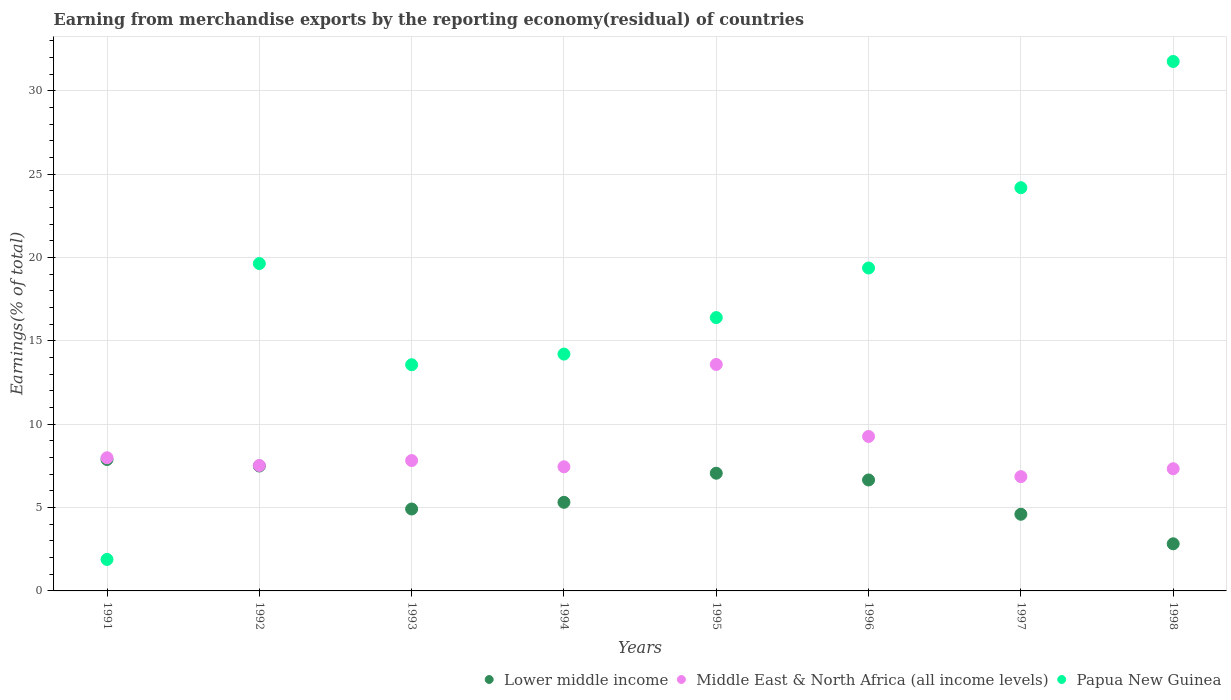How many different coloured dotlines are there?
Provide a succinct answer. 3. What is the percentage of amount earned from merchandise exports in Lower middle income in 1998?
Ensure brevity in your answer.  2.83. Across all years, what is the maximum percentage of amount earned from merchandise exports in Lower middle income?
Your response must be concise. 7.88. Across all years, what is the minimum percentage of amount earned from merchandise exports in Middle East & North Africa (all income levels)?
Offer a very short reply. 6.86. In which year was the percentage of amount earned from merchandise exports in Lower middle income maximum?
Offer a terse response. 1991. What is the total percentage of amount earned from merchandise exports in Papua New Guinea in the graph?
Your answer should be very brief. 141. What is the difference between the percentage of amount earned from merchandise exports in Papua New Guinea in 1994 and that in 1996?
Ensure brevity in your answer.  -5.16. What is the difference between the percentage of amount earned from merchandise exports in Lower middle income in 1997 and the percentage of amount earned from merchandise exports in Middle East & North Africa (all income levels) in 1996?
Provide a short and direct response. -4.67. What is the average percentage of amount earned from merchandise exports in Papua New Guinea per year?
Provide a short and direct response. 17.62. In the year 1993, what is the difference between the percentage of amount earned from merchandise exports in Middle East & North Africa (all income levels) and percentage of amount earned from merchandise exports in Lower middle income?
Make the answer very short. 2.91. In how many years, is the percentage of amount earned from merchandise exports in Middle East & North Africa (all income levels) greater than 25 %?
Offer a very short reply. 0. What is the ratio of the percentage of amount earned from merchandise exports in Lower middle income in 1993 to that in 1995?
Your answer should be compact. 0.7. Is the difference between the percentage of amount earned from merchandise exports in Middle East & North Africa (all income levels) in 1994 and 1998 greater than the difference between the percentage of amount earned from merchandise exports in Lower middle income in 1994 and 1998?
Your answer should be very brief. No. What is the difference between the highest and the second highest percentage of amount earned from merchandise exports in Middle East & North Africa (all income levels)?
Offer a very short reply. 4.32. What is the difference between the highest and the lowest percentage of amount earned from merchandise exports in Lower middle income?
Give a very brief answer. 5.06. Does the percentage of amount earned from merchandise exports in Lower middle income monotonically increase over the years?
Your answer should be compact. No. Is the percentage of amount earned from merchandise exports in Middle East & North Africa (all income levels) strictly greater than the percentage of amount earned from merchandise exports in Lower middle income over the years?
Make the answer very short. Yes. How many dotlines are there?
Offer a very short reply. 3. How many years are there in the graph?
Provide a short and direct response. 8. What is the difference between two consecutive major ticks on the Y-axis?
Offer a terse response. 5. Are the values on the major ticks of Y-axis written in scientific E-notation?
Make the answer very short. No. Does the graph contain any zero values?
Provide a short and direct response. No. Does the graph contain grids?
Keep it short and to the point. Yes. Where does the legend appear in the graph?
Ensure brevity in your answer.  Bottom right. How many legend labels are there?
Offer a very short reply. 3. What is the title of the graph?
Give a very brief answer. Earning from merchandise exports by the reporting economy(residual) of countries. Does "India" appear as one of the legend labels in the graph?
Keep it short and to the point. No. What is the label or title of the Y-axis?
Provide a short and direct response. Earnings(% of total). What is the Earnings(% of total) of Lower middle income in 1991?
Offer a terse response. 7.88. What is the Earnings(% of total) in Middle East & North Africa (all income levels) in 1991?
Offer a very short reply. 7.99. What is the Earnings(% of total) in Papua New Guinea in 1991?
Provide a short and direct response. 1.89. What is the Earnings(% of total) of Lower middle income in 1992?
Offer a very short reply. 7.49. What is the Earnings(% of total) of Middle East & North Africa (all income levels) in 1992?
Your answer should be very brief. 7.52. What is the Earnings(% of total) of Papua New Guinea in 1992?
Provide a succinct answer. 19.64. What is the Earnings(% of total) in Lower middle income in 1993?
Offer a very short reply. 4.91. What is the Earnings(% of total) of Middle East & North Africa (all income levels) in 1993?
Your answer should be very brief. 7.82. What is the Earnings(% of total) in Papua New Guinea in 1993?
Keep it short and to the point. 13.57. What is the Earnings(% of total) in Lower middle income in 1994?
Make the answer very short. 5.32. What is the Earnings(% of total) in Middle East & North Africa (all income levels) in 1994?
Keep it short and to the point. 7.45. What is the Earnings(% of total) in Papua New Guinea in 1994?
Provide a short and direct response. 14.21. What is the Earnings(% of total) in Lower middle income in 1995?
Offer a very short reply. 7.06. What is the Earnings(% of total) of Middle East & North Africa (all income levels) in 1995?
Offer a very short reply. 13.58. What is the Earnings(% of total) in Papua New Guinea in 1995?
Give a very brief answer. 16.39. What is the Earnings(% of total) of Lower middle income in 1996?
Provide a short and direct response. 6.66. What is the Earnings(% of total) in Middle East & North Africa (all income levels) in 1996?
Your answer should be compact. 9.26. What is the Earnings(% of total) in Papua New Guinea in 1996?
Make the answer very short. 19.37. What is the Earnings(% of total) of Lower middle income in 1997?
Offer a very short reply. 4.6. What is the Earnings(% of total) in Middle East & North Africa (all income levels) in 1997?
Your answer should be compact. 6.86. What is the Earnings(% of total) of Papua New Guinea in 1997?
Your response must be concise. 24.19. What is the Earnings(% of total) in Lower middle income in 1998?
Provide a succinct answer. 2.83. What is the Earnings(% of total) of Middle East & North Africa (all income levels) in 1998?
Offer a terse response. 7.33. What is the Earnings(% of total) in Papua New Guinea in 1998?
Your answer should be very brief. 31.76. Across all years, what is the maximum Earnings(% of total) in Lower middle income?
Provide a short and direct response. 7.88. Across all years, what is the maximum Earnings(% of total) of Middle East & North Africa (all income levels)?
Keep it short and to the point. 13.58. Across all years, what is the maximum Earnings(% of total) in Papua New Guinea?
Provide a short and direct response. 31.76. Across all years, what is the minimum Earnings(% of total) of Lower middle income?
Ensure brevity in your answer.  2.83. Across all years, what is the minimum Earnings(% of total) in Middle East & North Africa (all income levels)?
Your answer should be compact. 6.86. Across all years, what is the minimum Earnings(% of total) of Papua New Guinea?
Give a very brief answer. 1.89. What is the total Earnings(% of total) of Lower middle income in the graph?
Keep it short and to the point. 46.74. What is the total Earnings(% of total) in Middle East & North Africa (all income levels) in the graph?
Your answer should be compact. 67.81. What is the total Earnings(% of total) in Papua New Guinea in the graph?
Give a very brief answer. 141. What is the difference between the Earnings(% of total) in Lower middle income in 1991 and that in 1992?
Offer a terse response. 0.39. What is the difference between the Earnings(% of total) in Middle East & North Africa (all income levels) in 1991 and that in 1992?
Provide a short and direct response. 0.46. What is the difference between the Earnings(% of total) in Papua New Guinea in 1991 and that in 1992?
Offer a terse response. -17.75. What is the difference between the Earnings(% of total) of Lower middle income in 1991 and that in 1993?
Ensure brevity in your answer.  2.97. What is the difference between the Earnings(% of total) of Middle East & North Africa (all income levels) in 1991 and that in 1993?
Your answer should be compact. 0.17. What is the difference between the Earnings(% of total) in Papua New Guinea in 1991 and that in 1993?
Offer a very short reply. -11.68. What is the difference between the Earnings(% of total) in Lower middle income in 1991 and that in 1994?
Provide a succinct answer. 2.57. What is the difference between the Earnings(% of total) in Middle East & North Africa (all income levels) in 1991 and that in 1994?
Ensure brevity in your answer.  0.54. What is the difference between the Earnings(% of total) of Papua New Guinea in 1991 and that in 1994?
Your answer should be compact. -12.32. What is the difference between the Earnings(% of total) in Lower middle income in 1991 and that in 1995?
Provide a succinct answer. 0.82. What is the difference between the Earnings(% of total) of Middle East & North Africa (all income levels) in 1991 and that in 1995?
Your answer should be compact. -5.6. What is the difference between the Earnings(% of total) of Papua New Guinea in 1991 and that in 1995?
Your response must be concise. -14.51. What is the difference between the Earnings(% of total) of Lower middle income in 1991 and that in 1996?
Provide a short and direct response. 1.23. What is the difference between the Earnings(% of total) in Middle East & North Africa (all income levels) in 1991 and that in 1996?
Your answer should be compact. -1.28. What is the difference between the Earnings(% of total) of Papua New Guinea in 1991 and that in 1996?
Your answer should be compact. -17.48. What is the difference between the Earnings(% of total) of Lower middle income in 1991 and that in 1997?
Offer a terse response. 3.29. What is the difference between the Earnings(% of total) of Middle East & North Africa (all income levels) in 1991 and that in 1997?
Offer a terse response. 1.13. What is the difference between the Earnings(% of total) of Papua New Guinea in 1991 and that in 1997?
Offer a terse response. -22.3. What is the difference between the Earnings(% of total) in Lower middle income in 1991 and that in 1998?
Your answer should be very brief. 5.06. What is the difference between the Earnings(% of total) of Middle East & North Africa (all income levels) in 1991 and that in 1998?
Ensure brevity in your answer.  0.66. What is the difference between the Earnings(% of total) of Papua New Guinea in 1991 and that in 1998?
Offer a very short reply. -29.87. What is the difference between the Earnings(% of total) in Lower middle income in 1992 and that in 1993?
Your response must be concise. 2.58. What is the difference between the Earnings(% of total) in Middle East & North Africa (all income levels) in 1992 and that in 1993?
Give a very brief answer. -0.29. What is the difference between the Earnings(% of total) in Papua New Guinea in 1992 and that in 1993?
Your answer should be compact. 6.07. What is the difference between the Earnings(% of total) of Lower middle income in 1992 and that in 1994?
Provide a succinct answer. 2.18. What is the difference between the Earnings(% of total) of Middle East & North Africa (all income levels) in 1992 and that in 1994?
Give a very brief answer. 0.08. What is the difference between the Earnings(% of total) of Papua New Guinea in 1992 and that in 1994?
Ensure brevity in your answer.  5.43. What is the difference between the Earnings(% of total) of Lower middle income in 1992 and that in 1995?
Ensure brevity in your answer.  0.43. What is the difference between the Earnings(% of total) in Middle East & North Africa (all income levels) in 1992 and that in 1995?
Your response must be concise. -6.06. What is the difference between the Earnings(% of total) of Papua New Guinea in 1992 and that in 1995?
Ensure brevity in your answer.  3.24. What is the difference between the Earnings(% of total) in Lower middle income in 1992 and that in 1996?
Offer a terse response. 0.84. What is the difference between the Earnings(% of total) of Middle East & North Africa (all income levels) in 1992 and that in 1996?
Provide a succinct answer. -1.74. What is the difference between the Earnings(% of total) of Papua New Guinea in 1992 and that in 1996?
Your answer should be compact. 0.27. What is the difference between the Earnings(% of total) in Lower middle income in 1992 and that in 1997?
Offer a terse response. 2.89. What is the difference between the Earnings(% of total) of Middle East & North Africa (all income levels) in 1992 and that in 1997?
Offer a very short reply. 0.67. What is the difference between the Earnings(% of total) in Papua New Guinea in 1992 and that in 1997?
Your response must be concise. -4.55. What is the difference between the Earnings(% of total) in Lower middle income in 1992 and that in 1998?
Your answer should be very brief. 4.67. What is the difference between the Earnings(% of total) in Middle East & North Africa (all income levels) in 1992 and that in 1998?
Your answer should be compact. 0.2. What is the difference between the Earnings(% of total) of Papua New Guinea in 1992 and that in 1998?
Keep it short and to the point. -12.12. What is the difference between the Earnings(% of total) in Lower middle income in 1993 and that in 1994?
Ensure brevity in your answer.  -0.4. What is the difference between the Earnings(% of total) of Middle East & North Africa (all income levels) in 1993 and that in 1994?
Offer a very short reply. 0.37. What is the difference between the Earnings(% of total) in Papua New Guinea in 1993 and that in 1994?
Make the answer very short. -0.64. What is the difference between the Earnings(% of total) in Lower middle income in 1993 and that in 1995?
Offer a terse response. -2.15. What is the difference between the Earnings(% of total) of Middle East & North Africa (all income levels) in 1993 and that in 1995?
Offer a terse response. -5.76. What is the difference between the Earnings(% of total) in Papua New Guinea in 1993 and that in 1995?
Offer a terse response. -2.83. What is the difference between the Earnings(% of total) in Lower middle income in 1993 and that in 1996?
Offer a terse response. -1.74. What is the difference between the Earnings(% of total) in Middle East & North Africa (all income levels) in 1993 and that in 1996?
Give a very brief answer. -1.45. What is the difference between the Earnings(% of total) in Papua New Guinea in 1993 and that in 1996?
Offer a very short reply. -5.8. What is the difference between the Earnings(% of total) in Lower middle income in 1993 and that in 1997?
Offer a very short reply. 0.32. What is the difference between the Earnings(% of total) in Middle East & North Africa (all income levels) in 1993 and that in 1997?
Provide a short and direct response. 0.96. What is the difference between the Earnings(% of total) in Papua New Guinea in 1993 and that in 1997?
Your response must be concise. -10.62. What is the difference between the Earnings(% of total) of Lower middle income in 1993 and that in 1998?
Your answer should be very brief. 2.09. What is the difference between the Earnings(% of total) in Middle East & North Africa (all income levels) in 1993 and that in 1998?
Ensure brevity in your answer.  0.49. What is the difference between the Earnings(% of total) of Papua New Guinea in 1993 and that in 1998?
Your answer should be compact. -18.19. What is the difference between the Earnings(% of total) of Lower middle income in 1994 and that in 1995?
Ensure brevity in your answer.  -1.74. What is the difference between the Earnings(% of total) in Middle East & North Africa (all income levels) in 1994 and that in 1995?
Offer a very short reply. -6.14. What is the difference between the Earnings(% of total) of Papua New Guinea in 1994 and that in 1995?
Provide a short and direct response. -2.19. What is the difference between the Earnings(% of total) in Lower middle income in 1994 and that in 1996?
Keep it short and to the point. -1.34. What is the difference between the Earnings(% of total) in Middle East & North Africa (all income levels) in 1994 and that in 1996?
Make the answer very short. -1.82. What is the difference between the Earnings(% of total) of Papua New Guinea in 1994 and that in 1996?
Give a very brief answer. -5.16. What is the difference between the Earnings(% of total) of Lower middle income in 1994 and that in 1997?
Your answer should be very brief. 0.72. What is the difference between the Earnings(% of total) of Middle East & North Africa (all income levels) in 1994 and that in 1997?
Make the answer very short. 0.59. What is the difference between the Earnings(% of total) of Papua New Guinea in 1994 and that in 1997?
Offer a terse response. -9.98. What is the difference between the Earnings(% of total) in Lower middle income in 1994 and that in 1998?
Your response must be concise. 2.49. What is the difference between the Earnings(% of total) of Middle East & North Africa (all income levels) in 1994 and that in 1998?
Offer a terse response. 0.12. What is the difference between the Earnings(% of total) in Papua New Guinea in 1994 and that in 1998?
Offer a very short reply. -17.55. What is the difference between the Earnings(% of total) in Lower middle income in 1995 and that in 1996?
Your answer should be compact. 0.4. What is the difference between the Earnings(% of total) of Middle East & North Africa (all income levels) in 1995 and that in 1996?
Ensure brevity in your answer.  4.32. What is the difference between the Earnings(% of total) in Papua New Guinea in 1995 and that in 1996?
Make the answer very short. -2.97. What is the difference between the Earnings(% of total) in Lower middle income in 1995 and that in 1997?
Your response must be concise. 2.46. What is the difference between the Earnings(% of total) in Middle East & North Africa (all income levels) in 1995 and that in 1997?
Your answer should be compact. 6.73. What is the difference between the Earnings(% of total) of Papua New Guinea in 1995 and that in 1997?
Keep it short and to the point. -7.79. What is the difference between the Earnings(% of total) of Lower middle income in 1995 and that in 1998?
Offer a very short reply. 4.23. What is the difference between the Earnings(% of total) in Middle East & North Africa (all income levels) in 1995 and that in 1998?
Offer a very short reply. 6.25. What is the difference between the Earnings(% of total) of Papua New Guinea in 1995 and that in 1998?
Keep it short and to the point. -15.36. What is the difference between the Earnings(% of total) of Lower middle income in 1996 and that in 1997?
Provide a succinct answer. 2.06. What is the difference between the Earnings(% of total) of Middle East & North Africa (all income levels) in 1996 and that in 1997?
Offer a terse response. 2.41. What is the difference between the Earnings(% of total) in Papua New Guinea in 1996 and that in 1997?
Offer a very short reply. -4.82. What is the difference between the Earnings(% of total) in Lower middle income in 1996 and that in 1998?
Your answer should be compact. 3.83. What is the difference between the Earnings(% of total) of Middle East & North Africa (all income levels) in 1996 and that in 1998?
Offer a terse response. 1.94. What is the difference between the Earnings(% of total) in Papua New Guinea in 1996 and that in 1998?
Ensure brevity in your answer.  -12.39. What is the difference between the Earnings(% of total) in Lower middle income in 1997 and that in 1998?
Give a very brief answer. 1.77. What is the difference between the Earnings(% of total) of Middle East & North Africa (all income levels) in 1997 and that in 1998?
Keep it short and to the point. -0.47. What is the difference between the Earnings(% of total) of Papua New Guinea in 1997 and that in 1998?
Provide a succinct answer. -7.57. What is the difference between the Earnings(% of total) of Lower middle income in 1991 and the Earnings(% of total) of Middle East & North Africa (all income levels) in 1992?
Your answer should be very brief. 0.36. What is the difference between the Earnings(% of total) of Lower middle income in 1991 and the Earnings(% of total) of Papua New Guinea in 1992?
Ensure brevity in your answer.  -11.75. What is the difference between the Earnings(% of total) in Middle East & North Africa (all income levels) in 1991 and the Earnings(% of total) in Papua New Guinea in 1992?
Ensure brevity in your answer.  -11.65. What is the difference between the Earnings(% of total) of Lower middle income in 1991 and the Earnings(% of total) of Middle East & North Africa (all income levels) in 1993?
Make the answer very short. 0.06. What is the difference between the Earnings(% of total) in Lower middle income in 1991 and the Earnings(% of total) in Papua New Guinea in 1993?
Provide a succinct answer. -5.68. What is the difference between the Earnings(% of total) in Middle East & North Africa (all income levels) in 1991 and the Earnings(% of total) in Papua New Guinea in 1993?
Ensure brevity in your answer.  -5.58. What is the difference between the Earnings(% of total) in Lower middle income in 1991 and the Earnings(% of total) in Middle East & North Africa (all income levels) in 1994?
Offer a very short reply. 0.44. What is the difference between the Earnings(% of total) in Lower middle income in 1991 and the Earnings(% of total) in Papua New Guinea in 1994?
Give a very brief answer. -6.32. What is the difference between the Earnings(% of total) of Middle East & North Africa (all income levels) in 1991 and the Earnings(% of total) of Papua New Guinea in 1994?
Provide a short and direct response. -6.22. What is the difference between the Earnings(% of total) of Lower middle income in 1991 and the Earnings(% of total) of Middle East & North Africa (all income levels) in 1995?
Offer a terse response. -5.7. What is the difference between the Earnings(% of total) in Lower middle income in 1991 and the Earnings(% of total) in Papua New Guinea in 1995?
Your response must be concise. -8.51. What is the difference between the Earnings(% of total) in Middle East & North Africa (all income levels) in 1991 and the Earnings(% of total) in Papua New Guinea in 1995?
Offer a very short reply. -8.41. What is the difference between the Earnings(% of total) of Lower middle income in 1991 and the Earnings(% of total) of Middle East & North Africa (all income levels) in 1996?
Offer a terse response. -1.38. What is the difference between the Earnings(% of total) of Lower middle income in 1991 and the Earnings(% of total) of Papua New Guinea in 1996?
Offer a very short reply. -11.48. What is the difference between the Earnings(% of total) of Middle East & North Africa (all income levels) in 1991 and the Earnings(% of total) of Papua New Guinea in 1996?
Make the answer very short. -11.38. What is the difference between the Earnings(% of total) in Lower middle income in 1991 and the Earnings(% of total) in Middle East & North Africa (all income levels) in 1997?
Make the answer very short. 1.03. What is the difference between the Earnings(% of total) of Lower middle income in 1991 and the Earnings(% of total) of Papua New Guinea in 1997?
Provide a short and direct response. -16.3. What is the difference between the Earnings(% of total) of Middle East & North Africa (all income levels) in 1991 and the Earnings(% of total) of Papua New Guinea in 1997?
Provide a succinct answer. -16.2. What is the difference between the Earnings(% of total) of Lower middle income in 1991 and the Earnings(% of total) of Middle East & North Africa (all income levels) in 1998?
Your response must be concise. 0.56. What is the difference between the Earnings(% of total) of Lower middle income in 1991 and the Earnings(% of total) of Papua New Guinea in 1998?
Keep it short and to the point. -23.87. What is the difference between the Earnings(% of total) of Middle East & North Africa (all income levels) in 1991 and the Earnings(% of total) of Papua New Guinea in 1998?
Your response must be concise. -23.77. What is the difference between the Earnings(% of total) of Lower middle income in 1992 and the Earnings(% of total) of Middle East & North Africa (all income levels) in 1993?
Your response must be concise. -0.33. What is the difference between the Earnings(% of total) of Lower middle income in 1992 and the Earnings(% of total) of Papua New Guinea in 1993?
Offer a very short reply. -6.07. What is the difference between the Earnings(% of total) in Middle East & North Africa (all income levels) in 1992 and the Earnings(% of total) in Papua New Guinea in 1993?
Your answer should be compact. -6.04. What is the difference between the Earnings(% of total) in Lower middle income in 1992 and the Earnings(% of total) in Middle East & North Africa (all income levels) in 1994?
Your answer should be very brief. 0.05. What is the difference between the Earnings(% of total) in Lower middle income in 1992 and the Earnings(% of total) in Papua New Guinea in 1994?
Offer a very short reply. -6.71. What is the difference between the Earnings(% of total) of Middle East & North Africa (all income levels) in 1992 and the Earnings(% of total) of Papua New Guinea in 1994?
Ensure brevity in your answer.  -6.68. What is the difference between the Earnings(% of total) in Lower middle income in 1992 and the Earnings(% of total) in Middle East & North Africa (all income levels) in 1995?
Offer a terse response. -6.09. What is the difference between the Earnings(% of total) of Lower middle income in 1992 and the Earnings(% of total) of Papua New Guinea in 1995?
Offer a very short reply. -8.9. What is the difference between the Earnings(% of total) in Middle East & North Africa (all income levels) in 1992 and the Earnings(% of total) in Papua New Guinea in 1995?
Your response must be concise. -8.87. What is the difference between the Earnings(% of total) in Lower middle income in 1992 and the Earnings(% of total) in Middle East & North Africa (all income levels) in 1996?
Your answer should be very brief. -1.77. What is the difference between the Earnings(% of total) in Lower middle income in 1992 and the Earnings(% of total) in Papua New Guinea in 1996?
Offer a terse response. -11.88. What is the difference between the Earnings(% of total) of Middle East & North Africa (all income levels) in 1992 and the Earnings(% of total) of Papua New Guinea in 1996?
Offer a terse response. -11.84. What is the difference between the Earnings(% of total) of Lower middle income in 1992 and the Earnings(% of total) of Middle East & North Africa (all income levels) in 1997?
Provide a succinct answer. 0.64. What is the difference between the Earnings(% of total) in Lower middle income in 1992 and the Earnings(% of total) in Papua New Guinea in 1997?
Give a very brief answer. -16.69. What is the difference between the Earnings(% of total) in Middle East & North Africa (all income levels) in 1992 and the Earnings(% of total) in Papua New Guinea in 1997?
Your response must be concise. -16.66. What is the difference between the Earnings(% of total) in Lower middle income in 1992 and the Earnings(% of total) in Middle East & North Africa (all income levels) in 1998?
Your answer should be very brief. 0.16. What is the difference between the Earnings(% of total) of Lower middle income in 1992 and the Earnings(% of total) of Papua New Guinea in 1998?
Keep it short and to the point. -24.26. What is the difference between the Earnings(% of total) in Middle East & North Africa (all income levels) in 1992 and the Earnings(% of total) in Papua New Guinea in 1998?
Ensure brevity in your answer.  -24.23. What is the difference between the Earnings(% of total) in Lower middle income in 1993 and the Earnings(% of total) in Middle East & North Africa (all income levels) in 1994?
Keep it short and to the point. -2.53. What is the difference between the Earnings(% of total) in Lower middle income in 1993 and the Earnings(% of total) in Papua New Guinea in 1994?
Keep it short and to the point. -9.29. What is the difference between the Earnings(% of total) in Middle East & North Africa (all income levels) in 1993 and the Earnings(% of total) in Papua New Guinea in 1994?
Offer a terse response. -6.39. What is the difference between the Earnings(% of total) of Lower middle income in 1993 and the Earnings(% of total) of Middle East & North Africa (all income levels) in 1995?
Offer a terse response. -8.67. What is the difference between the Earnings(% of total) in Lower middle income in 1993 and the Earnings(% of total) in Papua New Guinea in 1995?
Keep it short and to the point. -11.48. What is the difference between the Earnings(% of total) in Middle East & North Africa (all income levels) in 1993 and the Earnings(% of total) in Papua New Guinea in 1995?
Your answer should be very brief. -8.58. What is the difference between the Earnings(% of total) of Lower middle income in 1993 and the Earnings(% of total) of Middle East & North Africa (all income levels) in 1996?
Offer a terse response. -4.35. What is the difference between the Earnings(% of total) of Lower middle income in 1993 and the Earnings(% of total) of Papua New Guinea in 1996?
Provide a succinct answer. -14.45. What is the difference between the Earnings(% of total) in Middle East & North Africa (all income levels) in 1993 and the Earnings(% of total) in Papua New Guinea in 1996?
Ensure brevity in your answer.  -11.55. What is the difference between the Earnings(% of total) in Lower middle income in 1993 and the Earnings(% of total) in Middle East & North Africa (all income levels) in 1997?
Make the answer very short. -1.94. What is the difference between the Earnings(% of total) of Lower middle income in 1993 and the Earnings(% of total) of Papua New Guinea in 1997?
Ensure brevity in your answer.  -19.27. What is the difference between the Earnings(% of total) of Middle East & North Africa (all income levels) in 1993 and the Earnings(% of total) of Papua New Guinea in 1997?
Provide a short and direct response. -16.37. What is the difference between the Earnings(% of total) in Lower middle income in 1993 and the Earnings(% of total) in Middle East & North Africa (all income levels) in 1998?
Provide a short and direct response. -2.41. What is the difference between the Earnings(% of total) in Lower middle income in 1993 and the Earnings(% of total) in Papua New Guinea in 1998?
Your answer should be very brief. -26.84. What is the difference between the Earnings(% of total) in Middle East & North Africa (all income levels) in 1993 and the Earnings(% of total) in Papua New Guinea in 1998?
Offer a very short reply. -23.94. What is the difference between the Earnings(% of total) in Lower middle income in 1994 and the Earnings(% of total) in Middle East & North Africa (all income levels) in 1995?
Your answer should be compact. -8.27. What is the difference between the Earnings(% of total) of Lower middle income in 1994 and the Earnings(% of total) of Papua New Guinea in 1995?
Your answer should be compact. -11.08. What is the difference between the Earnings(% of total) of Middle East & North Africa (all income levels) in 1994 and the Earnings(% of total) of Papua New Guinea in 1995?
Offer a terse response. -8.95. What is the difference between the Earnings(% of total) in Lower middle income in 1994 and the Earnings(% of total) in Middle East & North Africa (all income levels) in 1996?
Provide a succinct answer. -3.95. What is the difference between the Earnings(% of total) of Lower middle income in 1994 and the Earnings(% of total) of Papua New Guinea in 1996?
Your answer should be compact. -14.05. What is the difference between the Earnings(% of total) of Middle East & North Africa (all income levels) in 1994 and the Earnings(% of total) of Papua New Guinea in 1996?
Make the answer very short. -11.92. What is the difference between the Earnings(% of total) of Lower middle income in 1994 and the Earnings(% of total) of Middle East & North Africa (all income levels) in 1997?
Your answer should be compact. -1.54. What is the difference between the Earnings(% of total) of Lower middle income in 1994 and the Earnings(% of total) of Papua New Guinea in 1997?
Your answer should be very brief. -18.87. What is the difference between the Earnings(% of total) in Middle East & North Africa (all income levels) in 1994 and the Earnings(% of total) in Papua New Guinea in 1997?
Provide a short and direct response. -16.74. What is the difference between the Earnings(% of total) of Lower middle income in 1994 and the Earnings(% of total) of Middle East & North Africa (all income levels) in 1998?
Your answer should be compact. -2.01. What is the difference between the Earnings(% of total) of Lower middle income in 1994 and the Earnings(% of total) of Papua New Guinea in 1998?
Your response must be concise. -26.44. What is the difference between the Earnings(% of total) of Middle East & North Africa (all income levels) in 1994 and the Earnings(% of total) of Papua New Guinea in 1998?
Your response must be concise. -24.31. What is the difference between the Earnings(% of total) of Lower middle income in 1995 and the Earnings(% of total) of Middle East & North Africa (all income levels) in 1996?
Your answer should be compact. -2.21. What is the difference between the Earnings(% of total) of Lower middle income in 1995 and the Earnings(% of total) of Papua New Guinea in 1996?
Your answer should be compact. -12.31. What is the difference between the Earnings(% of total) in Middle East & North Africa (all income levels) in 1995 and the Earnings(% of total) in Papua New Guinea in 1996?
Offer a terse response. -5.79. What is the difference between the Earnings(% of total) in Lower middle income in 1995 and the Earnings(% of total) in Middle East & North Africa (all income levels) in 1997?
Provide a short and direct response. 0.2. What is the difference between the Earnings(% of total) of Lower middle income in 1995 and the Earnings(% of total) of Papua New Guinea in 1997?
Offer a very short reply. -17.13. What is the difference between the Earnings(% of total) in Middle East & North Africa (all income levels) in 1995 and the Earnings(% of total) in Papua New Guinea in 1997?
Keep it short and to the point. -10.6. What is the difference between the Earnings(% of total) in Lower middle income in 1995 and the Earnings(% of total) in Middle East & North Africa (all income levels) in 1998?
Make the answer very short. -0.27. What is the difference between the Earnings(% of total) of Lower middle income in 1995 and the Earnings(% of total) of Papua New Guinea in 1998?
Provide a short and direct response. -24.7. What is the difference between the Earnings(% of total) in Middle East & North Africa (all income levels) in 1995 and the Earnings(% of total) in Papua New Guinea in 1998?
Ensure brevity in your answer.  -18.17. What is the difference between the Earnings(% of total) in Lower middle income in 1996 and the Earnings(% of total) in Middle East & North Africa (all income levels) in 1997?
Make the answer very short. -0.2. What is the difference between the Earnings(% of total) in Lower middle income in 1996 and the Earnings(% of total) in Papua New Guinea in 1997?
Provide a succinct answer. -17.53. What is the difference between the Earnings(% of total) in Middle East & North Africa (all income levels) in 1996 and the Earnings(% of total) in Papua New Guinea in 1997?
Give a very brief answer. -14.92. What is the difference between the Earnings(% of total) of Lower middle income in 1996 and the Earnings(% of total) of Middle East & North Africa (all income levels) in 1998?
Ensure brevity in your answer.  -0.67. What is the difference between the Earnings(% of total) of Lower middle income in 1996 and the Earnings(% of total) of Papua New Guinea in 1998?
Your answer should be compact. -25.1. What is the difference between the Earnings(% of total) of Middle East & North Africa (all income levels) in 1996 and the Earnings(% of total) of Papua New Guinea in 1998?
Offer a terse response. -22.49. What is the difference between the Earnings(% of total) of Lower middle income in 1997 and the Earnings(% of total) of Middle East & North Africa (all income levels) in 1998?
Provide a succinct answer. -2.73. What is the difference between the Earnings(% of total) in Lower middle income in 1997 and the Earnings(% of total) in Papua New Guinea in 1998?
Your answer should be compact. -27.16. What is the difference between the Earnings(% of total) in Middle East & North Africa (all income levels) in 1997 and the Earnings(% of total) in Papua New Guinea in 1998?
Ensure brevity in your answer.  -24.9. What is the average Earnings(% of total) of Lower middle income per year?
Your answer should be compact. 5.84. What is the average Earnings(% of total) of Middle East & North Africa (all income levels) per year?
Offer a terse response. 8.48. What is the average Earnings(% of total) in Papua New Guinea per year?
Provide a succinct answer. 17.62. In the year 1991, what is the difference between the Earnings(% of total) of Lower middle income and Earnings(% of total) of Middle East & North Africa (all income levels)?
Ensure brevity in your answer.  -0.1. In the year 1991, what is the difference between the Earnings(% of total) in Lower middle income and Earnings(% of total) in Papua New Guinea?
Your response must be concise. 5.99. In the year 1991, what is the difference between the Earnings(% of total) in Middle East & North Africa (all income levels) and Earnings(% of total) in Papua New Guinea?
Your response must be concise. 6.1. In the year 1992, what is the difference between the Earnings(% of total) in Lower middle income and Earnings(% of total) in Middle East & North Africa (all income levels)?
Give a very brief answer. -0.03. In the year 1992, what is the difference between the Earnings(% of total) in Lower middle income and Earnings(% of total) in Papua New Guinea?
Ensure brevity in your answer.  -12.14. In the year 1992, what is the difference between the Earnings(% of total) in Middle East & North Africa (all income levels) and Earnings(% of total) in Papua New Guinea?
Give a very brief answer. -12.11. In the year 1993, what is the difference between the Earnings(% of total) of Lower middle income and Earnings(% of total) of Middle East & North Africa (all income levels)?
Keep it short and to the point. -2.91. In the year 1993, what is the difference between the Earnings(% of total) of Lower middle income and Earnings(% of total) of Papua New Guinea?
Keep it short and to the point. -8.65. In the year 1993, what is the difference between the Earnings(% of total) of Middle East & North Africa (all income levels) and Earnings(% of total) of Papua New Guinea?
Provide a succinct answer. -5.75. In the year 1994, what is the difference between the Earnings(% of total) of Lower middle income and Earnings(% of total) of Middle East & North Africa (all income levels)?
Make the answer very short. -2.13. In the year 1994, what is the difference between the Earnings(% of total) of Lower middle income and Earnings(% of total) of Papua New Guinea?
Give a very brief answer. -8.89. In the year 1994, what is the difference between the Earnings(% of total) of Middle East & North Africa (all income levels) and Earnings(% of total) of Papua New Guinea?
Provide a succinct answer. -6.76. In the year 1995, what is the difference between the Earnings(% of total) of Lower middle income and Earnings(% of total) of Middle East & North Africa (all income levels)?
Offer a very short reply. -6.52. In the year 1995, what is the difference between the Earnings(% of total) of Lower middle income and Earnings(% of total) of Papua New Guinea?
Offer a terse response. -9.34. In the year 1995, what is the difference between the Earnings(% of total) of Middle East & North Africa (all income levels) and Earnings(% of total) of Papua New Guinea?
Offer a very short reply. -2.81. In the year 1996, what is the difference between the Earnings(% of total) of Lower middle income and Earnings(% of total) of Middle East & North Africa (all income levels)?
Keep it short and to the point. -2.61. In the year 1996, what is the difference between the Earnings(% of total) of Lower middle income and Earnings(% of total) of Papua New Guinea?
Keep it short and to the point. -12.71. In the year 1996, what is the difference between the Earnings(% of total) in Middle East & North Africa (all income levels) and Earnings(% of total) in Papua New Guinea?
Your answer should be very brief. -10.1. In the year 1997, what is the difference between the Earnings(% of total) of Lower middle income and Earnings(% of total) of Middle East & North Africa (all income levels)?
Your answer should be compact. -2.26. In the year 1997, what is the difference between the Earnings(% of total) in Lower middle income and Earnings(% of total) in Papua New Guinea?
Offer a terse response. -19.59. In the year 1997, what is the difference between the Earnings(% of total) in Middle East & North Africa (all income levels) and Earnings(% of total) in Papua New Guinea?
Provide a short and direct response. -17.33. In the year 1998, what is the difference between the Earnings(% of total) of Lower middle income and Earnings(% of total) of Middle East & North Africa (all income levels)?
Make the answer very short. -4.5. In the year 1998, what is the difference between the Earnings(% of total) in Lower middle income and Earnings(% of total) in Papua New Guinea?
Offer a terse response. -28.93. In the year 1998, what is the difference between the Earnings(% of total) in Middle East & North Africa (all income levels) and Earnings(% of total) in Papua New Guinea?
Offer a terse response. -24.43. What is the ratio of the Earnings(% of total) of Lower middle income in 1991 to that in 1992?
Your answer should be compact. 1.05. What is the ratio of the Earnings(% of total) of Middle East & North Africa (all income levels) in 1991 to that in 1992?
Your response must be concise. 1.06. What is the ratio of the Earnings(% of total) of Papua New Guinea in 1991 to that in 1992?
Offer a very short reply. 0.1. What is the ratio of the Earnings(% of total) of Lower middle income in 1991 to that in 1993?
Offer a very short reply. 1.6. What is the ratio of the Earnings(% of total) in Middle East & North Africa (all income levels) in 1991 to that in 1993?
Offer a very short reply. 1.02. What is the ratio of the Earnings(% of total) of Papua New Guinea in 1991 to that in 1993?
Provide a succinct answer. 0.14. What is the ratio of the Earnings(% of total) of Lower middle income in 1991 to that in 1994?
Make the answer very short. 1.48. What is the ratio of the Earnings(% of total) of Middle East & North Africa (all income levels) in 1991 to that in 1994?
Your answer should be compact. 1.07. What is the ratio of the Earnings(% of total) of Papua New Guinea in 1991 to that in 1994?
Make the answer very short. 0.13. What is the ratio of the Earnings(% of total) in Lower middle income in 1991 to that in 1995?
Offer a very short reply. 1.12. What is the ratio of the Earnings(% of total) of Middle East & North Africa (all income levels) in 1991 to that in 1995?
Your answer should be very brief. 0.59. What is the ratio of the Earnings(% of total) of Papua New Guinea in 1991 to that in 1995?
Give a very brief answer. 0.12. What is the ratio of the Earnings(% of total) in Lower middle income in 1991 to that in 1996?
Provide a succinct answer. 1.18. What is the ratio of the Earnings(% of total) in Middle East & North Africa (all income levels) in 1991 to that in 1996?
Provide a succinct answer. 0.86. What is the ratio of the Earnings(% of total) in Papua New Guinea in 1991 to that in 1996?
Provide a short and direct response. 0.1. What is the ratio of the Earnings(% of total) in Lower middle income in 1991 to that in 1997?
Offer a very short reply. 1.71. What is the ratio of the Earnings(% of total) in Middle East & North Africa (all income levels) in 1991 to that in 1997?
Your answer should be very brief. 1.16. What is the ratio of the Earnings(% of total) of Papua New Guinea in 1991 to that in 1997?
Ensure brevity in your answer.  0.08. What is the ratio of the Earnings(% of total) in Lower middle income in 1991 to that in 1998?
Ensure brevity in your answer.  2.79. What is the ratio of the Earnings(% of total) of Middle East & North Africa (all income levels) in 1991 to that in 1998?
Your answer should be compact. 1.09. What is the ratio of the Earnings(% of total) of Papua New Guinea in 1991 to that in 1998?
Your response must be concise. 0.06. What is the ratio of the Earnings(% of total) in Lower middle income in 1992 to that in 1993?
Your answer should be very brief. 1.52. What is the ratio of the Earnings(% of total) in Middle East & North Africa (all income levels) in 1992 to that in 1993?
Give a very brief answer. 0.96. What is the ratio of the Earnings(% of total) of Papua New Guinea in 1992 to that in 1993?
Provide a succinct answer. 1.45. What is the ratio of the Earnings(% of total) of Lower middle income in 1992 to that in 1994?
Ensure brevity in your answer.  1.41. What is the ratio of the Earnings(% of total) in Middle East & North Africa (all income levels) in 1992 to that in 1994?
Your answer should be compact. 1.01. What is the ratio of the Earnings(% of total) in Papua New Guinea in 1992 to that in 1994?
Give a very brief answer. 1.38. What is the ratio of the Earnings(% of total) of Lower middle income in 1992 to that in 1995?
Offer a terse response. 1.06. What is the ratio of the Earnings(% of total) of Middle East & North Africa (all income levels) in 1992 to that in 1995?
Your answer should be compact. 0.55. What is the ratio of the Earnings(% of total) in Papua New Guinea in 1992 to that in 1995?
Your response must be concise. 1.2. What is the ratio of the Earnings(% of total) in Lower middle income in 1992 to that in 1996?
Provide a succinct answer. 1.13. What is the ratio of the Earnings(% of total) of Middle East & North Africa (all income levels) in 1992 to that in 1996?
Make the answer very short. 0.81. What is the ratio of the Earnings(% of total) in Papua New Guinea in 1992 to that in 1996?
Make the answer very short. 1.01. What is the ratio of the Earnings(% of total) of Lower middle income in 1992 to that in 1997?
Ensure brevity in your answer.  1.63. What is the ratio of the Earnings(% of total) in Middle East & North Africa (all income levels) in 1992 to that in 1997?
Make the answer very short. 1.1. What is the ratio of the Earnings(% of total) in Papua New Guinea in 1992 to that in 1997?
Keep it short and to the point. 0.81. What is the ratio of the Earnings(% of total) of Lower middle income in 1992 to that in 1998?
Your answer should be compact. 2.65. What is the ratio of the Earnings(% of total) in Middle East & North Africa (all income levels) in 1992 to that in 1998?
Your response must be concise. 1.03. What is the ratio of the Earnings(% of total) in Papua New Guinea in 1992 to that in 1998?
Make the answer very short. 0.62. What is the ratio of the Earnings(% of total) of Lower middle income in 1993 to that in 1994?
Your answer should be compact. 0.92. What is the ratio of the Earnings(% of total) in Middle East & North Africa (all income levels) in 1993 to that in 1994?
Make the answer very short. 1.05. What is the ratio of the Earnings(% of total) of Papua New Guinea in 1993 to that in 1994?
Your answer should be compact. 0.95. What is the ratio of the Earnings(% of total) in Lower middle income in 1993 to that in 1995?
Your answer should be very brief. 0.7. What is the ratio of the Earnings(% of total) of Middle East & North Africa (all income levels) in 1993 to that in 1995?
Your answer should be very brief. 0.58. What is the ratio of the Earnings(% of total) of Papua New Guinea in 1993 to that in 1995?
Your answer should be very brief. 0.83. What is the ratio of the Earnings(% of total) in Lower middle income in 1993 to that in 1996?
Make the answer very short. 0.74. What is the ratio of the Earnings(% of total) of Middle East & North Africa (all income levels) in 1993 to that in 1996?
Make the answer very short. 0.84. What is the ratio of the Earnings(% of total) in Papua New Guinea in 1993 to that in 1996?
Your response must be concise. 0.7. What is the ratio of the Earnings(% of total) in Lower middle income in 1993 to that in 1997?
Offer a very short reply. 1.07. What is the ratio of the Earnings(% of total) in Middle East & North Africa (all income levels) in 1993 to that in 1997?
Your answer should be compact. 1.14. What is the ratio of the Earnings(% of total) in Papua New Guinea in 1993 to that in 1997?
Offer a very short reply. 0.56. What is the ratio of the Earnings(% of total) of Lower middle income in 1993 to that in 1998?
Offer a very short reply. 1.74. What is the ratio of the Earnings(% of total) in Middle East & North Africa (all income levels) in 1993 to that in 1998?
Your answer should be very brief. 1.07. What is the ratio of the Earnings(% of total) of Papua New Guinea in 1993 to that in 1998?
Your answer should be compact. 0.43. What is the ratio of the Earnings(% of total) in Lower middle income in 1994 to that in 1995?
Your response must be concise. 0.75. What is the ratio of the Earnings(% of total) of Middle East & North Africa (all income levels) in 1994 to that in 1995?
Provide a succinct answer. 0.55. What is the ratio of the Earnings(% of total) of Papua New Guinea in 1994 to that in 1995?
Ensure brevity in your answer.  0.87. What is the ratio of the Earnings(% of total) of Lower middle income in 1994 to that in 1996?
Give a very brief answer. 0.8. What is the ratio of the Earnings(% of total) in Middle East & North Africa (all income levels) in 1994 to that in 1996?
Provide a short and direct response. 0.8. What is the ratio of the Earnings(% of total) in Papua New Guinea in 1994 to that in 1996?
Offer a terse response. 0.73. What is the ratio of the Earnings(% of total) in Lower middle income in 1994 to that in 1997?
Offer a terse response. 1.16. What is the ratio of the Earnings(% of total) in Middle East & North Africa (all income levels) in 1994 to that in 1997?
Provide a succinct answer. 1.09. What is the ratio of the Earnings(% of total) in Papua New Guinea in 1994 to that in 1997?
Keep it short and to the point. 0.59. What is the ratio of the Earnings(% of total) of Lower middle income in 1994 to that in 1998?
Provide a succinct answer. 1.88. What is the ratio of the Earnings(% of total) of Papua New Guinea in 1994 to that in 1998?
Keep it short and to the point. 0.45. What is the ratio of the Earnings(% of total) of Lower middle income in 1995 to that in 1996?
Ensure brevity in your answer.  1.06. What is the ratio of the Earnings(% of total) of Middle East & North Africa (all income levels) in 1995 to that in 1996?
Make the answer very short. 1.47. What is the ratio of the Earnings(% of total) of Papua New Guinea in 1995 to that in 1996?
Give a very brief answer. 0.85. What is the ratio of the Earnings(% of total) of Lower middle income in 1995 to that in 1997?
Ensure brevity in your answer.  1.54. What is the ratio of the Earnings(% of total) of Middle East & North Africa (all income levels) in 1995 to that in 1997?
Offer a very short reply. 1.98. What is the ratio of the Earnings(% of total) of Papua New Guinea in 1995 to that in 1997?
Your response must be concise. 0.68. What is the ratio of the Earnings(% of total) in Lower middle income in 1995 to that in 1998?
Your answer should be compact. 2.5. What is the ratio of the Earnings(% of total) of Middle East & North Africa (all income levels) in 1995 to that in 1998?
Ensure brevity in your answer.  1.85. What is the ratio of the Earnings(% of total) of Papua New Guinea in 1995 to that in 1998?
Your answer should be very brief. 0.52. What is the ratio of the Earnings(% of total) of Lower middle income in 1996 to that in 1997?
Ensure brevity in your answer.  1.45. What is the ratio of the Earnings(% of total) of Middle East & North Africa (all income levels) in 1996 to that in 1997?
Your response must be concise. 1.35. What is the ratio of the Earnings(% of total) in Papua New Guinea in 1996 to that in 1997?
Provide a succinct answer. 0.8. What is the ratio of the Earnings(% of total) of Lower middle income in 1996 to that in 1998?
Make the answer very short. 2.36. What is the ratio of the Earnings(% of total) in Middle East & North Africa (all income levels) in 1996 to that in 1998?
Offer a very short reply. 1.26. What is the ratio of the Earnings(% of total) in Papua New Guinea in 1996 to that in 1998?
Your answer should be very brief. 0.61. What is the ratio of the Earnings(% of total) of Lower middle income in 1997 to that in 1998?
Provide a succinct answer. 1.63. What is the ratio of the Earnings(% of total) of Middle East & North Africa (all income levels) in 1997 to that in 1998?
Provide a short and direct response. 0.94. What is the ratio of the Earnings(% of total) of Papua New Guinea in 1997 to that in 1998?
Ensure brevity in your answer.  0.76. What is the difference between the highest and the second highest Earnings(% of total) in Lower middle income?
Your response must be concise. 0.39. What is the difference between the highest and the second highest Earnings(% of total) in Middle East & North Africa (all income levels)?
Keep it short and to the point. 4.32. What is the difference between the highest and the second highest Earnings(% of total) in Papua New Guinea?
Make the answer very short. 7.57. What is the difference between the highest and the lowest Earnings(% of total) in Lower middle income?
Ensure brevity in your answer.  5.06. What is the difference between the highest and the lowest Earnings(% of total) of Middle East & North Africa (all income levels)?
Keep it short and to the point. 6.73. What is the difference between the highest and the lowest Earnings(% of total) in Papua New Guinea?
Keep it short and to the point. 29.87. 